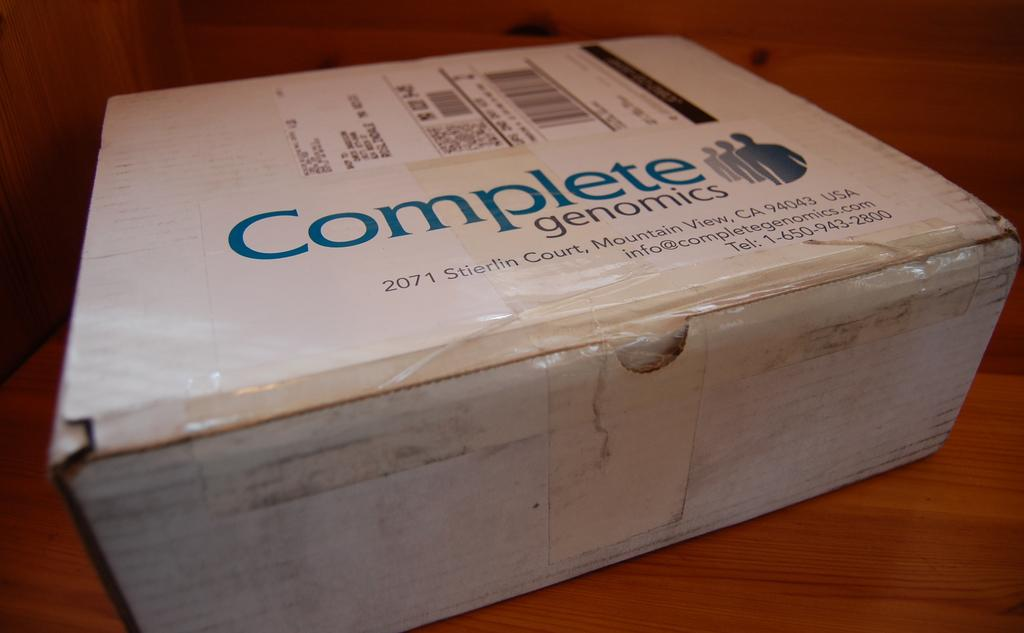<image>
Describe the image concisely. A package in a box from complete genomics. 